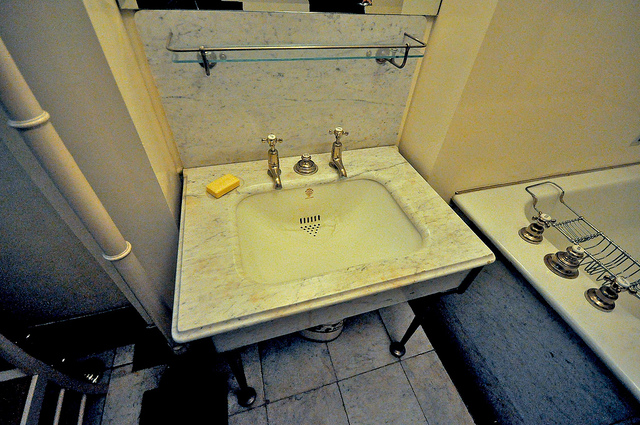Could you explain the purpose of the knobs on the sink and the bathtub? Certainly. The knobs on the sink and the bathtub serve to control the water's flow and temperature. Sinks typically have separate knobs for hot and cold water, enabling users to mix the two to achieve the desired temperature. Bathtubs often have multiple knobs to manage various functionalities, including filling the tub, switching the water flow to a showerhead, and adjusting the water temperature. 